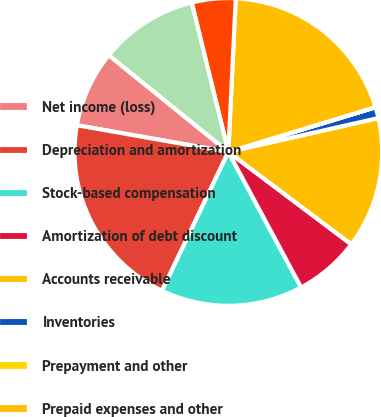Convert chart. <chart><loc_0><loc_0><loc_500><loc_500><pie_chart><fcel>Net income (loss)<fcel>Depreciation and amortization<fcel>Stock-based compensation<fcel>Amortization of debt discount<fcel>Accounts receivable<fcel>Inventories<fcel>Prepayment and other<fcel>Prepaid expenses and other<fcel>Payable to related parties<fcel>Accounts payable accrued<nl><fcel>8.05%<fcel>20.68%<fcel>14.94%<fcel>6.9%<fcel>13.79%<fcel>1.16%<fcel>0.01%<fcel>19.53%<fcel>4.6%<fcel>10.34%<nl></chart> 